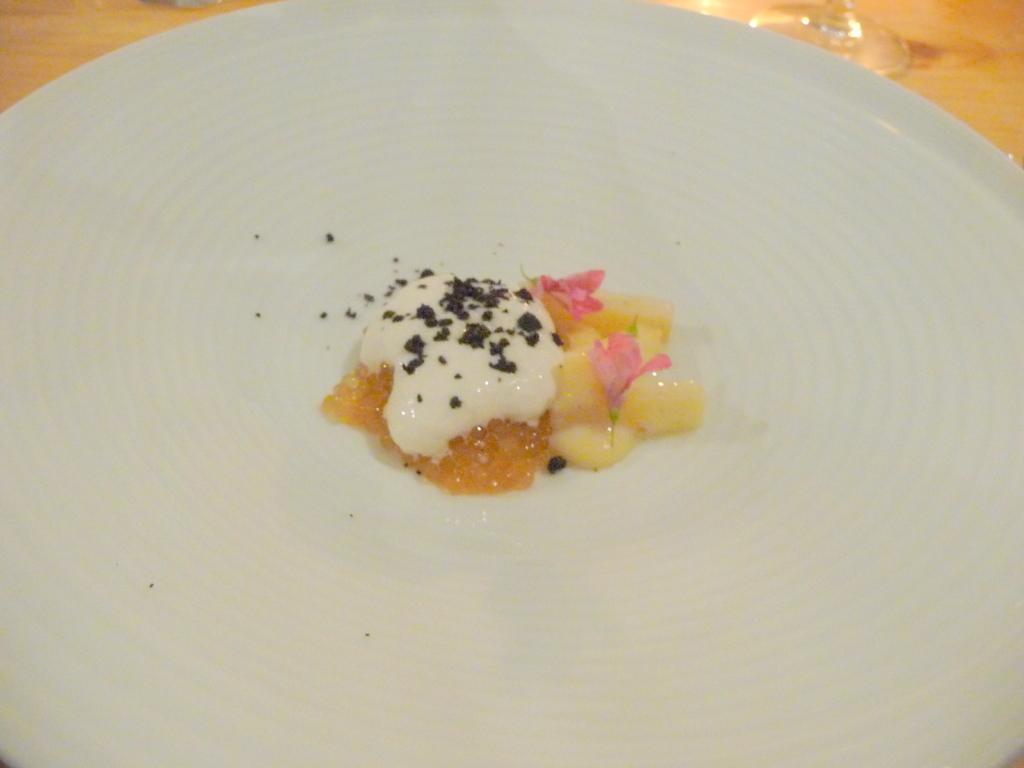Please provide a concise description of this image. In this image we can see food item on the plate, also we can see some part of the glass, which are on the wooden surface. 